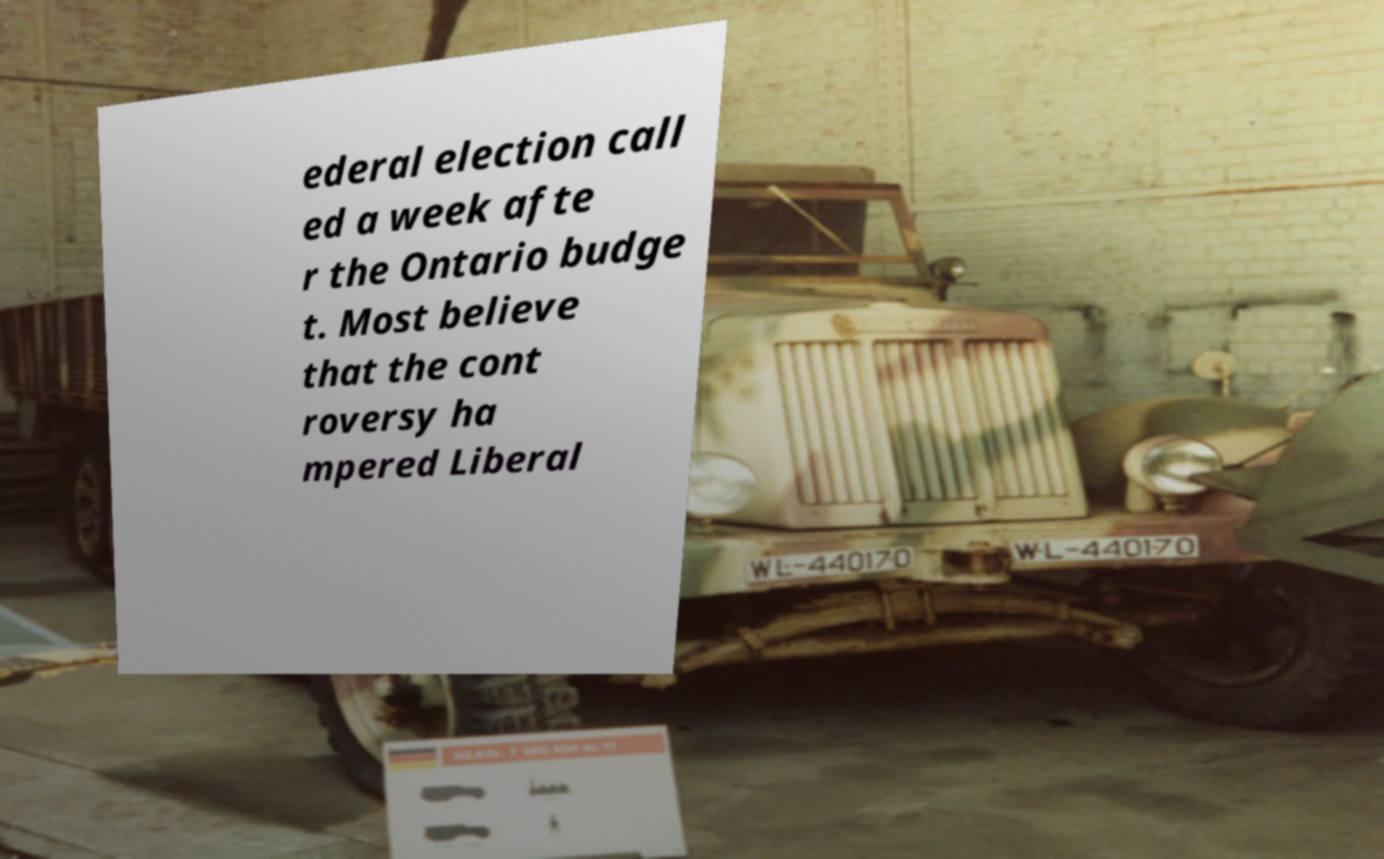There's text embedded in this image that I need extracted. Can you transcribe it verbatim? ederal election call ed a week afte r the Ontario budge t. Most believe that the cont roversy ha mpered Liberal 